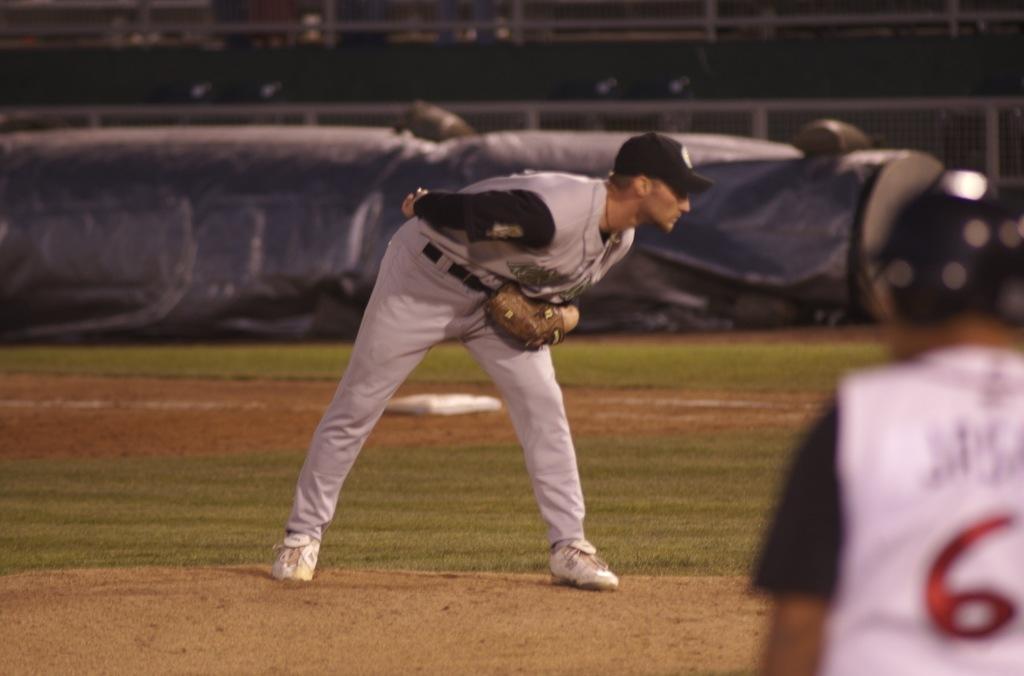What jersey number is on the players back?
Your answer should be very brief. 6. 